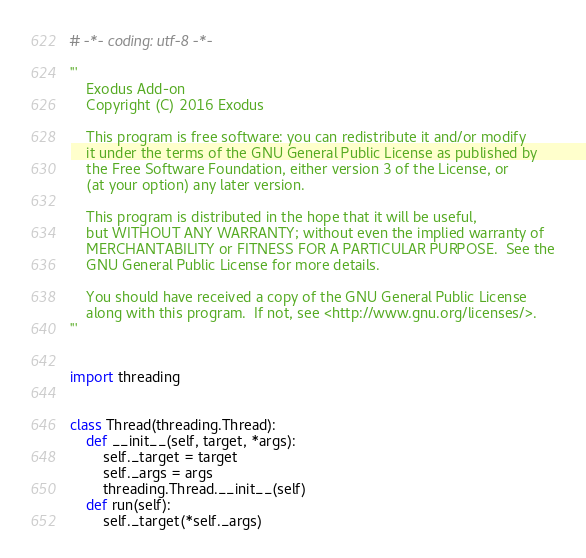<code> <loc_0><loc_0><loc_500><loc_500><_Python_># -*- coding: utf-8 -*-

'''
    Exodus Add-on
    Copyright (C) 2016 Exodus

    This program is free software: you can redistribute it and/or modify
    it under the terms of the GNU General Public License as published by
    the Free Software Foundation, either version 3 of the License, or
    (at your option) any later version.

    This program is distributed in the hope that it will be useful,
    but WITHOUT ANY WARRANTY; without even the implied warranty of
    MERCHANTABILITY or FITNESS FOR A PARTICULAR PURPOSE.  See the
    GNU General Public License for more details.

    You should have received a copy of the GNU General Public License
    along with this program.  If not, see <http://www.gnu.org/licenses/>.
'''


import threading


class Thread(threading.Thread):
    def __init__(self, target, *args):
        self._target = target
        self._args = args
        threading.Thread.__init__(self)
    def run(self):
        self._target(*self._args)

</code> 